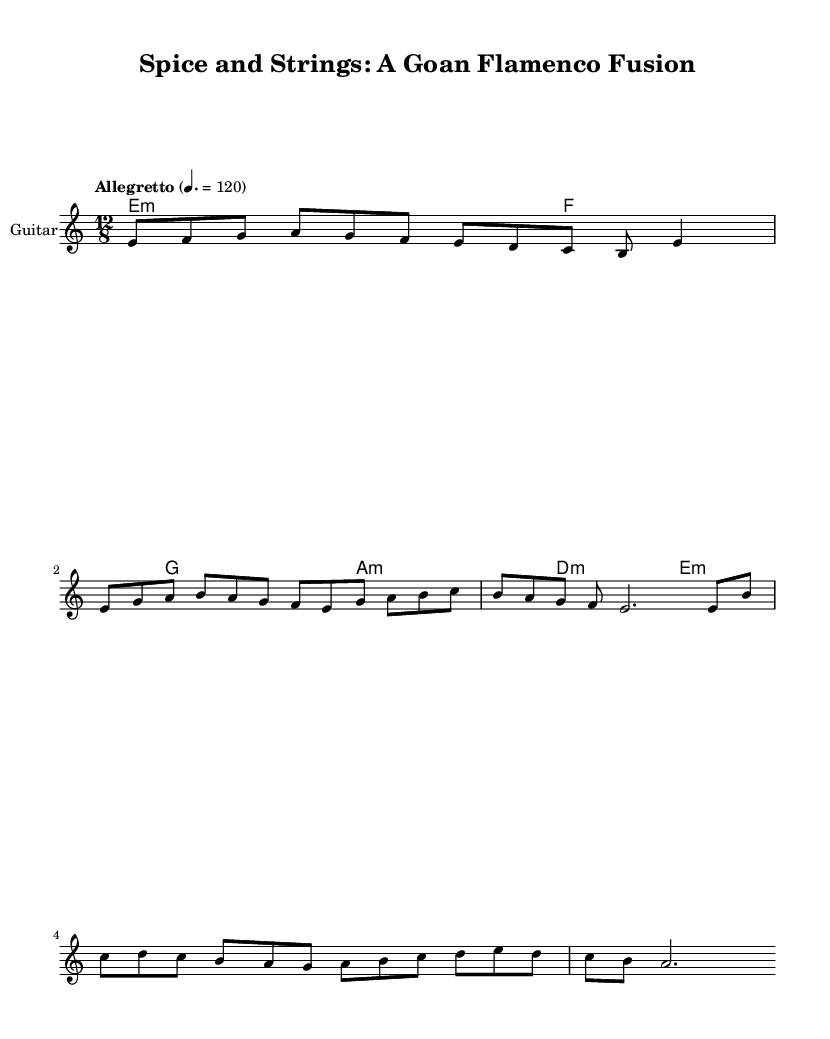What is the key signature of this music? The key signature is specified as E phrygian. This can be identified in the global settings where the key is declared using "\key e \phrygian".
Answer: E phrygian What is the time signature of this piece? The time signature is indicated by "\time 12/8" in the global settings. This means there are 12 beats in a measure, with an eighth note getting one beat.
Answer: 12/8 What is the tempo marking of this piece? The tempo marking is provided as "Allegretto" with a metronome mark of 120, which is indicated by "\tempo 'Allegretto' 4. = 120" in the code section.
Answer: Allegretto 120 How many measures are in the melody section? By counting the measures in the melody, there are a total of 5 lines of music with specific note groupings. Each line contains a specific number of notes that can be grouped into measures. The total gives us 5 measures.
Answer: 5 What type of guitar is specified for this music? The instrument name for the guitar is described as "Guitar" with a MIDI instrument specification of "acoustic guitar (nylon)" in the score setup.
Answer: Acoustic guitar (nylon) What is the structure of the song as indicated in the melody? The song structure consists of an intro followed by a verse and then a chorus. The measures are outlined clearly in the melody's comments section, indicating the transitions between these sections.
Answer: Intro, Verse, Chorus How many harmonies are present across the score? In the harmonies section, each chord is listed sequentially, with four distinct sections described in the \chordmode. This includes the unique minor chords with a total of 4 distinct harmonic instructions.
Answer: 4 